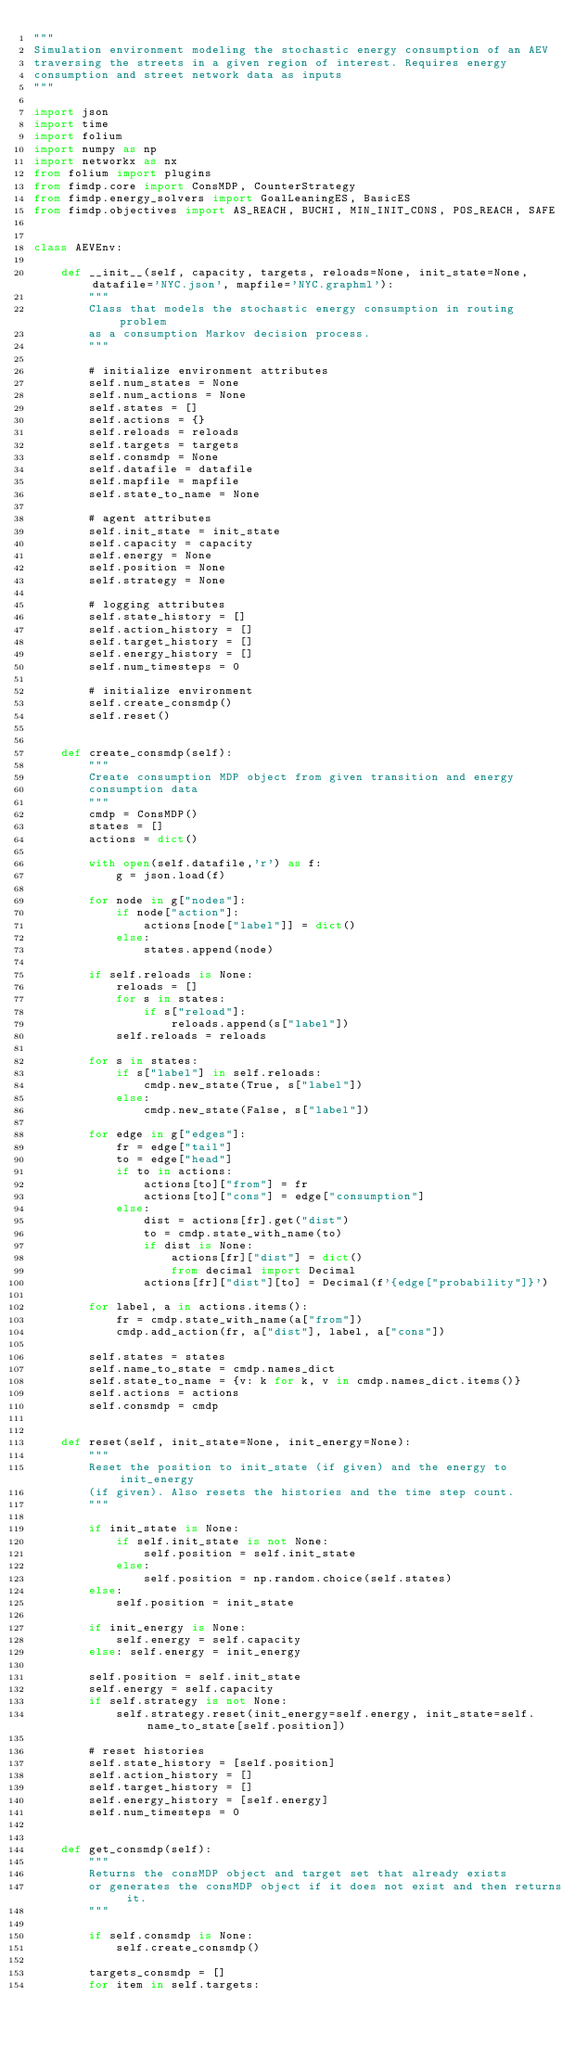Convert code to text. <code><loc_0><loc_0><loc_500><loc_500><_Python_>"""
Simulation environment modeling the stochastic energy consumption of an AEV
traversing the streets in a given region of interest. Requires energy
consumption and street network data as inputs
"""

import json
import time
import folium
import numpy as np
import networkx as nx
from folium import plugins
from fimdp.core import ConsMDP, CounterStrategy
from fimdp.energy_solvers import GoalLeaningES, BasicES
from fimdp.objectives import AS_REACH, BUCHI, MIN_INIT_CONS, POS_REACH, SAFE


class AEVEnv:
    
    def __init__(self, capacity, targets, reloads=None, init_state=None, datafile='NYC.json', mapfile='NYC.graphml'):
        """
        Class that models the stochastic energy consumption in routing problem
        as a consumption Markov decision process. 
        """
        
        # initialize environment attributes
        self.num_states = None
        self.num_actions = None
        self.states = []
        self.actions = {}
        self.reloads = reloads
        self.targets = targets
        self.consmdp = None
        self.datafile = datafile
        self.mapfile = mapfile
        self.state_to_name = None
        
        # agent attributes
        self.init_state = init_state
        self.capacity = capacity
        self.energy = None
        self.position = None
        self.strategy = None
        
        # logging attributes
        self.state_history = []
        self.action_history = []
        self.target_history = []
        self.energy_history = []
        self.num_timesteps = 0        
    
        # initialize environment
        self.create_consmdp()
        self.reset()

    
    def create_consmdp(self):
        """
        Create consumption MDP object from given transition and energy
        consumption data
        """
        cmdp = ConsMDP()
        states = []
        actions = dict()
        
        with open(self.datafile,'r') as f:
            g = json.load(f)
            
        for node in g["nodes"]:
            if node["action"]:
                actions[node["label"]] = dict()
            else:
                states.append(node)
        
        if self.reloads is None:
            reloads = []
            for s in states:
                if s["reload"]:
                    reloads.append(s["label"])
            self.reloads = reloads
            
        for s in states:
            if s["label"] in self.reloads:
                cmdp.new_state(True, s["label"])
            else:
                cmdp.new_state(False, s["label"])
                
        for edge in g["edges"]:
            fr = edge["tail"]
            to = edge["head"]
            if to in actions:
                actions[to]["from"] = fr
                actions[to]["cons"] = edge["consumption"]
            else:
                dist = actions[fr].get("dist")
                to = cmdp.state_with_name(to)
                if dist is None:
                    actions[fr]["dist"] = dict()
                    from decimal import Decimal
                actions[fr]["dist"][to] = Decimal(f'{edge["probability"]}')
                
        for label, a in actions.items():
            fr = cmdp.state_with_name(a["from"])
            cmdp.add_action(fr, a["dist"], label, a["cons"])
        
        self.states = states
        self.name_to_state = cmdp.names_dict
        self.state_to_name = {v: k for k, v in cmdp.names_dict.items()}
        self.actions = actions
        self.consmdp = cmdp
        
    
    def reset(self, init_state=None, init_energy=None):
        """
        Reset the position to init_state (if given) and the energy to init_energy
        (if given). Also resets the histories and the time step count.
        """
        
        if init_state is None:
            if self.init_state is not None:
                self.position = self.init_state
            else:
                self.position = np.random.choice(self.states)
        else:
            self.position = init_state
        
        if init_energy is None:
            self.energy = self.capacity
        else: self.energy = init_energy
            
        self.position = self.init_state
        self.energy = self.capacity
        if self.strategy is not None:
            self.strategy.reset(init_energy=self.energy, init_state=self.name_to_state[self.position])
        
        # reset histories
        self.state_history = [self.position]
        self.action_history = []
        self.target_history = []
        self.energy_history = [self.energy]
        self.num_timesteps = 0

        
    def get_consmdp(self):
        """
        Returns the consMDP object and target set that already exists
        or generates the consMDP object if it does not exist and then returns it.
        """
        
        if self.consmdp is None:
            self.create_consmdp()
            
        targets_consmdp = []
        for item in self.targets:</code> 